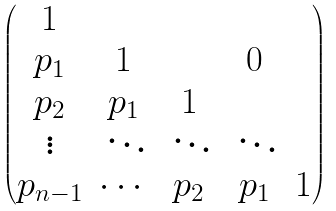<formula> <loc_0><loc_0><loc_500><loc_500>\begin{pmatrix} 1 & & & & \\ p _ { 1 } & 1 & & 0 & \\ p _ { 2 } & p _ { 1 } & 1 & & \\ \vdots & \, \ddots & \, \ddots & \, \ddots & \\ p _ { n - 1 } & \cdots & p _ { 2 } & p _ { 1 } & 1 \\ \end{pmatrix}</formula> 